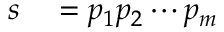<formula> <loc_0><loc_0><loc_500><loc_500>\begin{array} { r l } { s } & = p _ { 1 } p _ { 2 } \cdots p _ { m } } \end{array}</formula> 